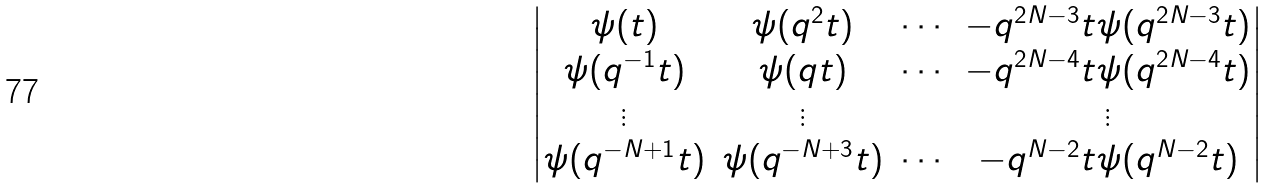Convert formula to latex. <formula><loc_0><loc_0><loc_500><loc_500>\begin{vmatrix} \psi ( t ) & \psi ( q ^ { 2 } t ) & \cdots & - q ^ { 2 N - 3 } t \psi ( q ^ { 2 N - 3 } t ) \\ \psi ( q ^ { - 1 } t ) & \psi ( q t ) & \cdots & - q ^ { 2 N - 4 } t \psi ( q ^ { 2 N - 4 } t ) \\ \vdots & \vdots & & \vdots \\ \psi ( q ^ { - N + 1 } t ) & \psi ( q ^ { - N + 3 } t ) & \cdots & - q ^ { N - 2 } t \psi ( q ^ { N - 2 } t ) \end{vmatrix}</formula> 